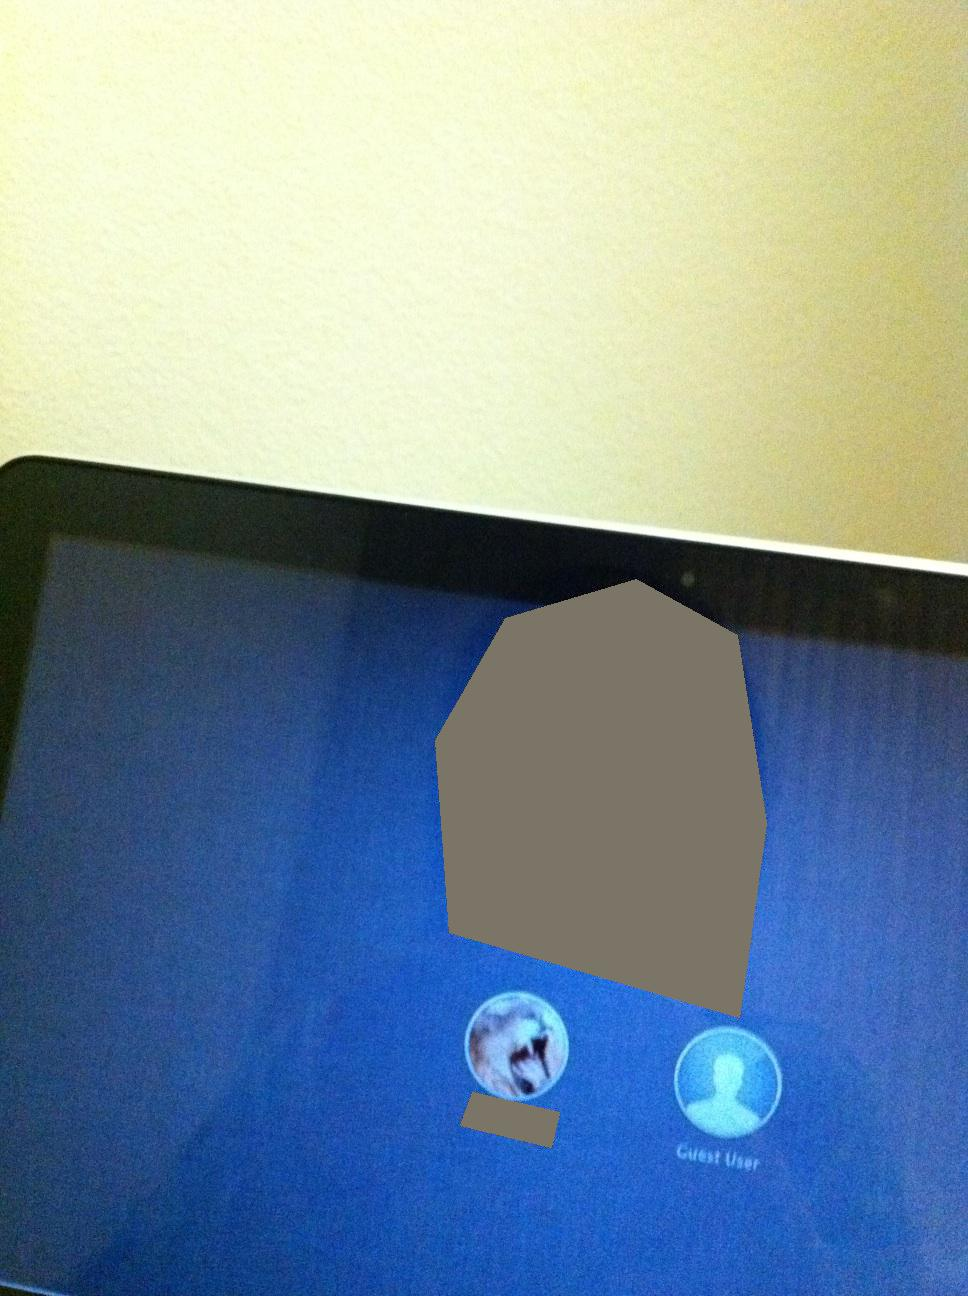What additional features or options might be typically available on a login screen like this? Typically, a login screen like this might have options to switch users, a field for entering a password, and possibly links or buttons for forgotten passwords. In some cases, there may be network settings or accessibility options available. 